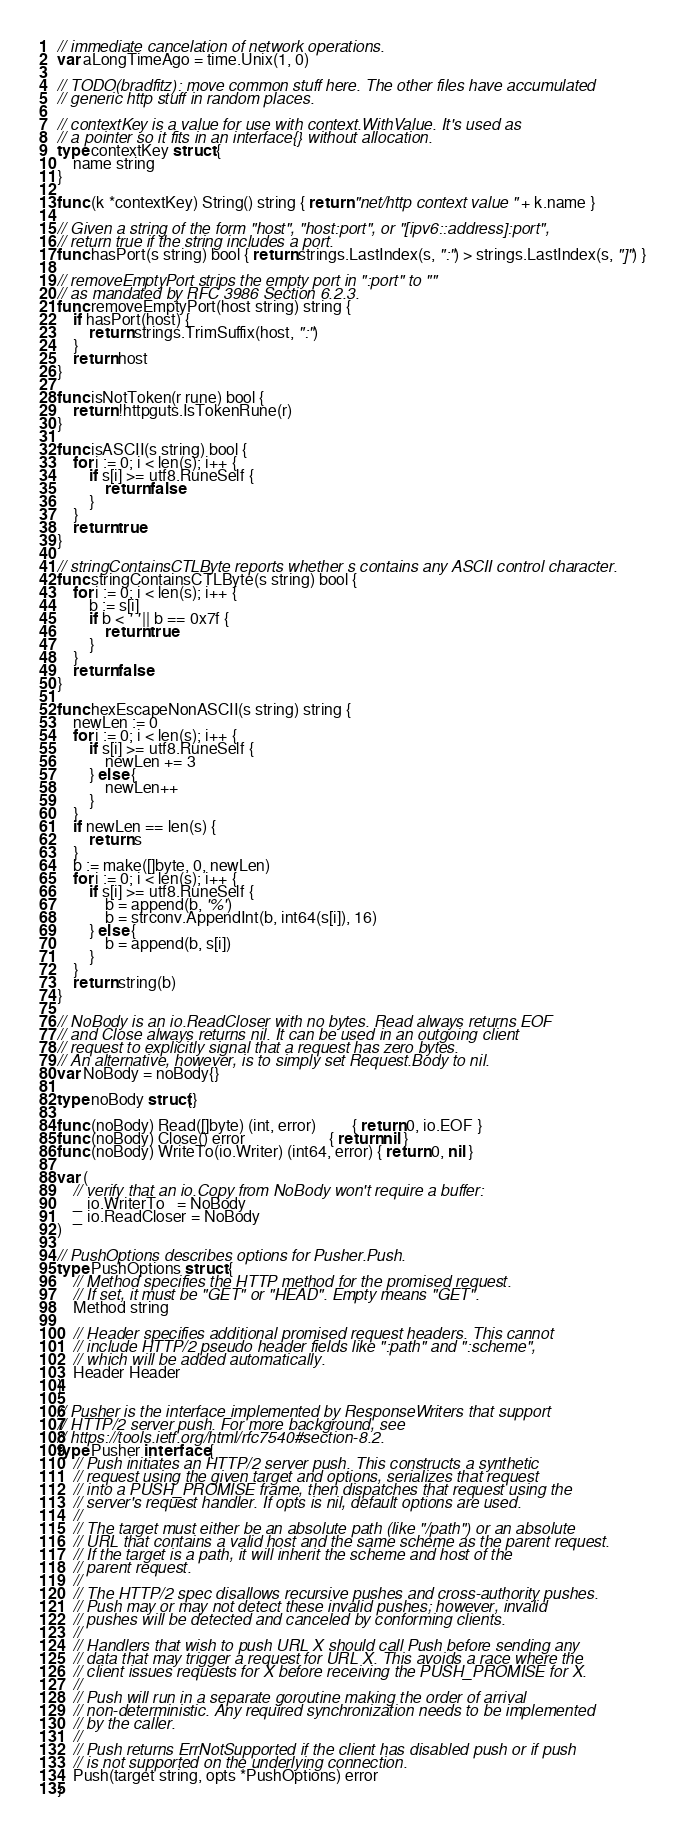<code> <loc_0><loc_0><loc_500><loc_500><_Go_>// immediate cancelation of network operations.
var aLongTimeAgo = time.Unix(1, 0)

// TODO(bradfitz): move common stuff here. The other files have accumulated
// generic http stuff in random places.

// contextKey is a value for use with context.WithValue. It's used as
// a pointer so it fits in an interface{} without allocation.
type contextKey struct {
	name string
}

func (k *contextKey) String() string { return "net/http context value " + k.name }

// Given a string of the form "host", "host:port", or "[ipv6::address]:port",
// return true if the string includes a port.
func hasPort(s string) bool { return strings.LastIndex(s, ":") > strings.LastIndex(s, "]") }

// removeEmptyPort strips the empty port in ":port" to ""
// as mandated by RFC 3986 Section 6.2.3.
func removeEmptyPort(host string) string {
	if hasPort(host) {
		return strings.TrimSuffix(host, ":")
	}
	return host
}

func isNotToken(r rune) bool {
	return !httpguts.IsTokenRune(r)
}

func isASCII(s string) bool {
	for i := 0; i < len(s); i++ {
		if s[i] >= utf8.RuneSelf {
			return false
		}
	}
	return true
}

// stringContainsCTLByte reports whether s contains any ASCII control character.
func stringContainsCTLByte(s string) bool {
	for i := 0; i < len(s); i++ {
		b := s[i]
		if b < ' ' || b == 0x7f {
			return true
		}
	}
	return false
}

func hexEscapeNonASCII(s string) string {
	newLen := 0
	for i := 0; i < len(s); i++ {
		if s[i] >= utf8.RuneSelf {
			newLen += 3
		} else {
			newLen++
		}
	}
	if newLen == len(s) {
		return s
	}
	b := make([]byte, 0, newLen)
	for i := 0; i < len(s); i++ {
		if s[i] >= utf8.RuneSelf {
			b = append(b, '%')
			b = strconv.AppendInt(b, int64(s[i]), 16)
		} else {
			b = append(b, s[i])
		}
	}
	return string(b)
}

// NoBody is an io.ReadCloser with no bytes. Read always returns EOF
// and Close always returns nil. It can be used in an outgoing client
// request to explicitly signal that a request has zero bytes.
// An alternative, however, is to simply set Request.Body to nil.
var NoBody = noBody{}

type noBody struct{}

func (noBody) Read([]byte) (int, error)         { return 0, io.EOF }
func (noBody) Close() error                     { return nil }
func (noBody) WriteTo(io.Writer) (int64, error) { return 0, nil }

var (
	// verify that an io.Copy from NoBody won't require a buffer:
	_ io.WriterTo   = NoBody
	_ io.ReadCloser = NoBody
)

// PushOptions describes options for Pusher.Push.
type PushOptions struct {
	// Method specifies the HTTP method for the promised request.
	// If set, it must be "GET" or "HEAD". Empty means "GET".
	Method string

	// Header specifies additional promised request headers. This cannot
	// include HTTP/2 pseudo header fields like ":path" and ":scheme",
	// which will be added automatically.
	Header Header
}

// Pusher is the interface implemented by ResponseWriters that support
// HTTP/2 server push. For more background, see
// https://tools.ietf.org/html/rfc7540#section-8.2.
type Pusher interface {
	// Push initiates an HTTP/2 server push. This constructs a synthetic
	// request using the given target and options, serializes that request
	// into a PUSH_PROMISE frame, then dispatches that request using the
	// server's request handler. If opts is nil, default options are used.
	//
	// The target must either be an absolute path (like "/path") or an absolute
	// URL that contains a valid host and the same scheme as the parent request.
	// If the target is a path, it will inherit the scheme and host of the
	// parent request.
	//
	// The HTTP/2 spec disallows recursive pushes and cross-authority pushes.
	// Push may or may not detect these invalid pushes; however, invalid
	// pushes will be detected and canceled by conforming clients.
	//
	// Handlers that wish to push URL X should call Push before sending any
	// data that may trigger a request for URL X. This avoids a race where the
	// client issues requests for X before receiving the PUSH_PROMISE for X.
	//
	// Push will run in a separate goroutine making the order of arrival
	// non-deterministic. Any required synchronization needs to be implemented
	// by the caller.
	//
	// Push returns ErrNotSupported if the client has disabled push or if push
	// is not supported on the underlying connection.
	Push(target string, opts *PushOptions) error
}
</code> 